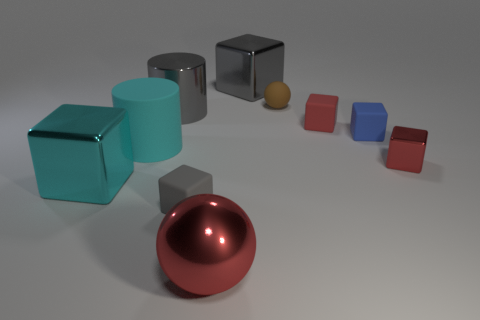There is a cyan shiny cube; are there any brown matte things to the left of it?
Keep it short and to the point. No. There is a big thing that is the same color as the large rubber cylinder; what is its material?
Your answer should be very brief. Metal. Is the large cylinder behind the small red rubber object made of the same material as the small brown thing?
Provide a short and direct response. No. There is a red thing left of the brown matte thing behind the large rubber thing; are there any big red things that are in front of it?
Your answer should be compact. No. How many blocks are big red shiny objects or large purple rubber objects?
Your response must be concise. 0. There is a large thing that is right of the big red object; what is its material?
Offer a very short reply. Metal. What size is the shiny cube that is the same color as the shiny cylinder?
Your answer should be very brief. Large. There is a small matte object in front of the big cyan block; is it the same color as the big cube on the right side of the large matte cylinder?
Make the answer very short. Yes. What number of objects are purple metal cylinders or gray shiny things?
Keep it short and to the point. 2. How many other things are the same shape as the blue rubber object?
Your response must be concise. 5. 